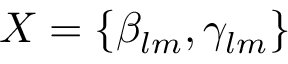Convert formula to latex. <formula><loc_0><loc_0><loc_500><loc_500>X = \left \{ { \beta _ { l m } , \gamma _ { l m } } \right \}</formula> 